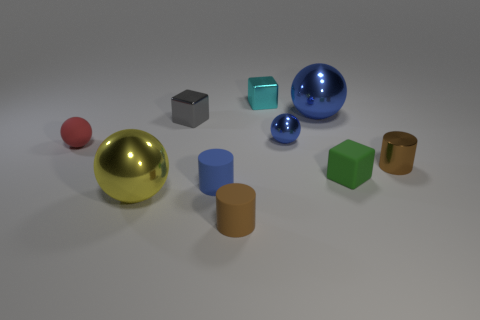Subtract all metallic spheres. How many spheres are left? 1 Subtract all red cylinders. How many blue spheres are left? 2 Subtract all red spheres. How many spheres are left? 3 Subtract 2 cylinders. How many cylinders are left? 1 Subtract all blocks. How many objects are left? 7 Subtract all purple blocks. Subtract all yellow balls. How many blocks are left? 3 Subtract all large shiny balls. Subtract all matte cylinders. How many objects are left? 6 Add 2 yellow metal balls. How many yellow metal balls are left? 3 Add 1 tiny green matte cubes. How many tiny green matte cubes exist? 2 Subtract 0 brown blocks. How many objects are left? 10 